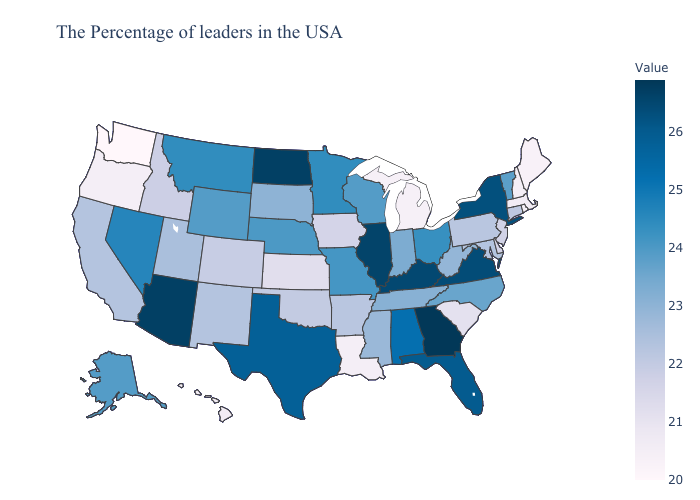Does the map have missing data?
Keep it brief. No. Is the legend a continuous bar?
Be succinct. Yes. Among the states that border Minnesota , does Iowa have the lowest value?
Short answer required. Yes. Does Michigan have the lowest value in the MidWest?
Answer briefly. Yes. 